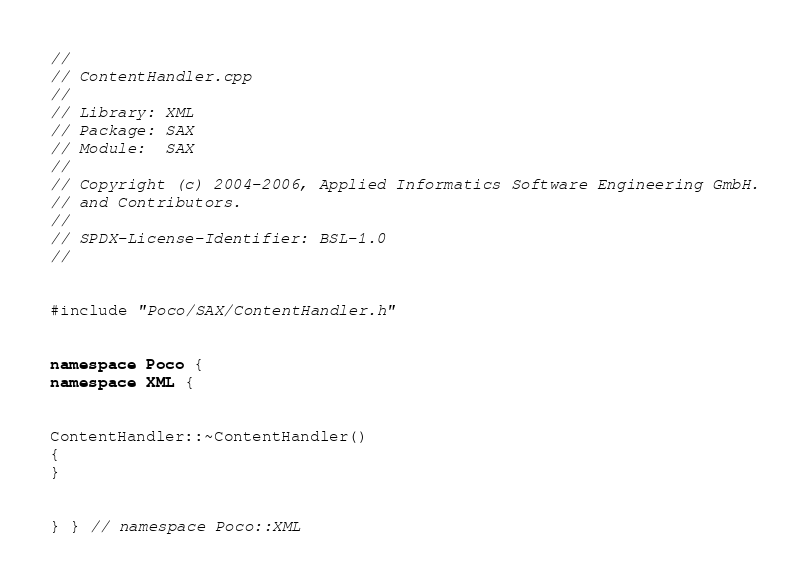<code> <loc_0><loc_0><loc_500><loc_500><_C++_>//
// ContentHandler.cpp
//
// Library: XML
// Package: SAX
// Module:  SAX
//
// Copyright (c) 2004-2006, Applied Informatics Software Engineering GmbH.
// and Contributors.
//
// SPDX-License-Identifier:	BSL-1.0
//


#include "Poco/SAX/ContentHandler.h"


namespace Poco {
namespace XML {


ContentHandler::~ContentHandler()
{
}


} } // namespace Poco::XML
</code> 